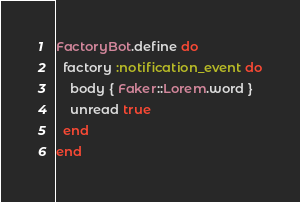<code> <loc_0><loc_0><loc_500><loc_500><_Ruby_>FactoryBot.define do
  factory :notification_event do
    body { Faker::Lorem.word }
    unread true
  end
end
</code> 